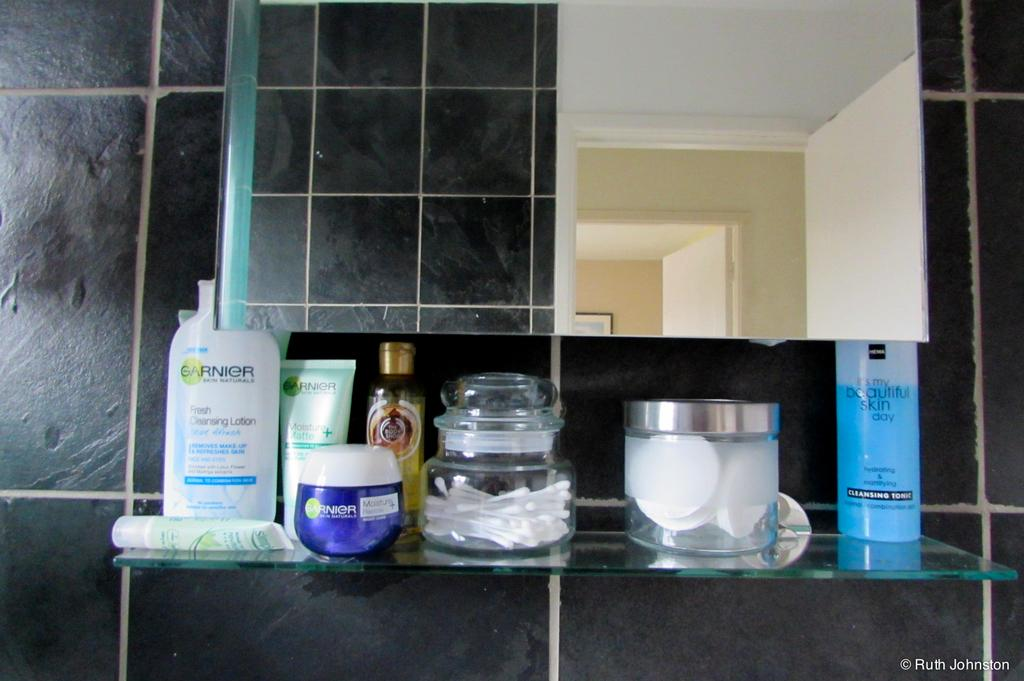<image>
Offer a succinct explanation of the picture presented. A bathroom shelf with toiletry products on it includinga bottle of Garnier. 